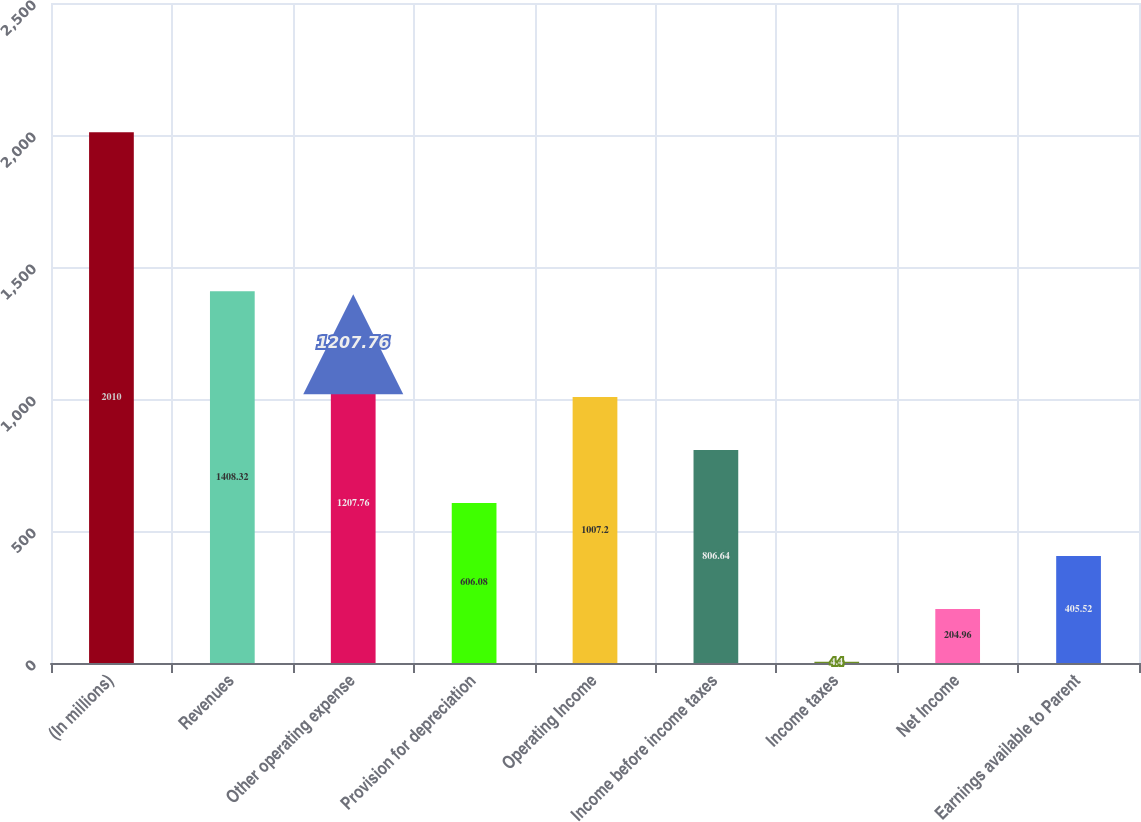Convert chart. <chart><loc_0><loc_0><loc_500><loc_500><bar_chart><fcel>(In millions)<fcel>Revenues<fcel>Other operating expense<fcel>Provision for depreciation<fcel>Operating Income<fcel>Income before income taxes<fcel>Income taxes<fcel>Net Income<fcel>Earnings available to Parent<nl><fcel>2010<fcel>1408.32<fcel>1207.76<fcel>606.08<fcel>1007.2<fcel>806.64<fcel>4.4<fcel>204.96<fcel>405.52<nl></chart> 